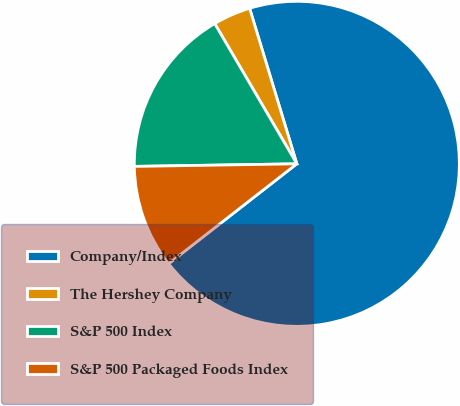Convert chart to OTSL. <chart><loc_0><loc_0><loc_500><loc_500><pie_chart><fcel>Company/Index<fcel>The Hershey Company<fcel>S&P 500 Index<fcel>S&P 500 Packaged Foods Index<nl><fcel>69.15%<fcel>3.74%<fcel>16.82%<fcel>10.28%<nl></chart> 